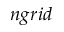Convert formula to latex. <formula><loc_0><loc_0><loc_500><loc_500>n g r i d</formula> 